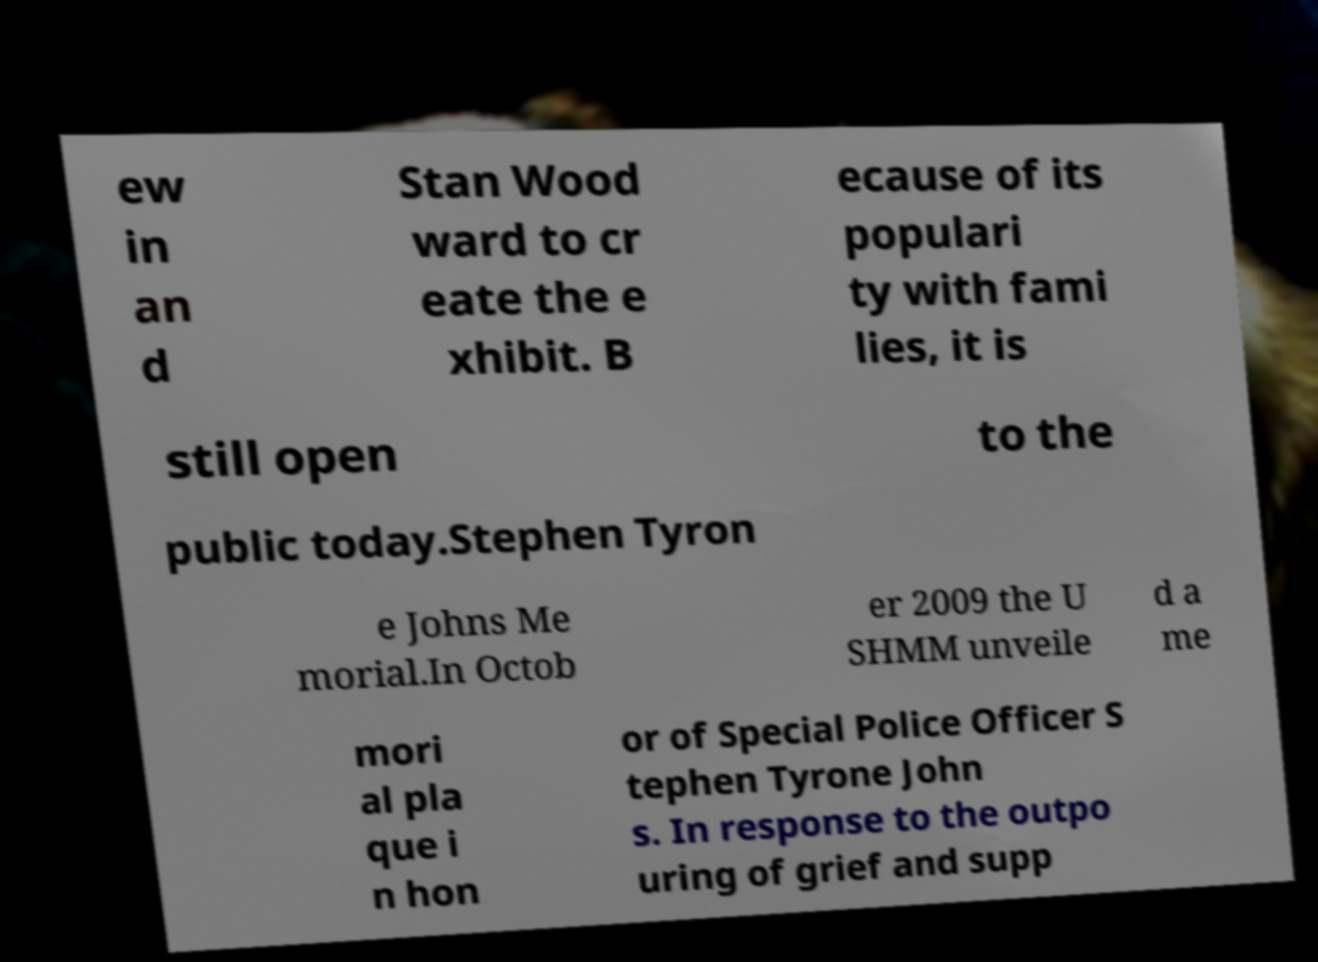Could you extract and type out the text from this image? ew in an d Stan Wood ward to cr eate the e xhibit. B ecause of its populari ty with fami lies, it is still open to the public today.Stephen Tyron e Johns Me morial.In Octob er 2009 the U SHMM unveile d a me mori al pla que i n hon or of Special Police Officer S tephen Tyrone John s. In response to the outpo uring of grief and supp 